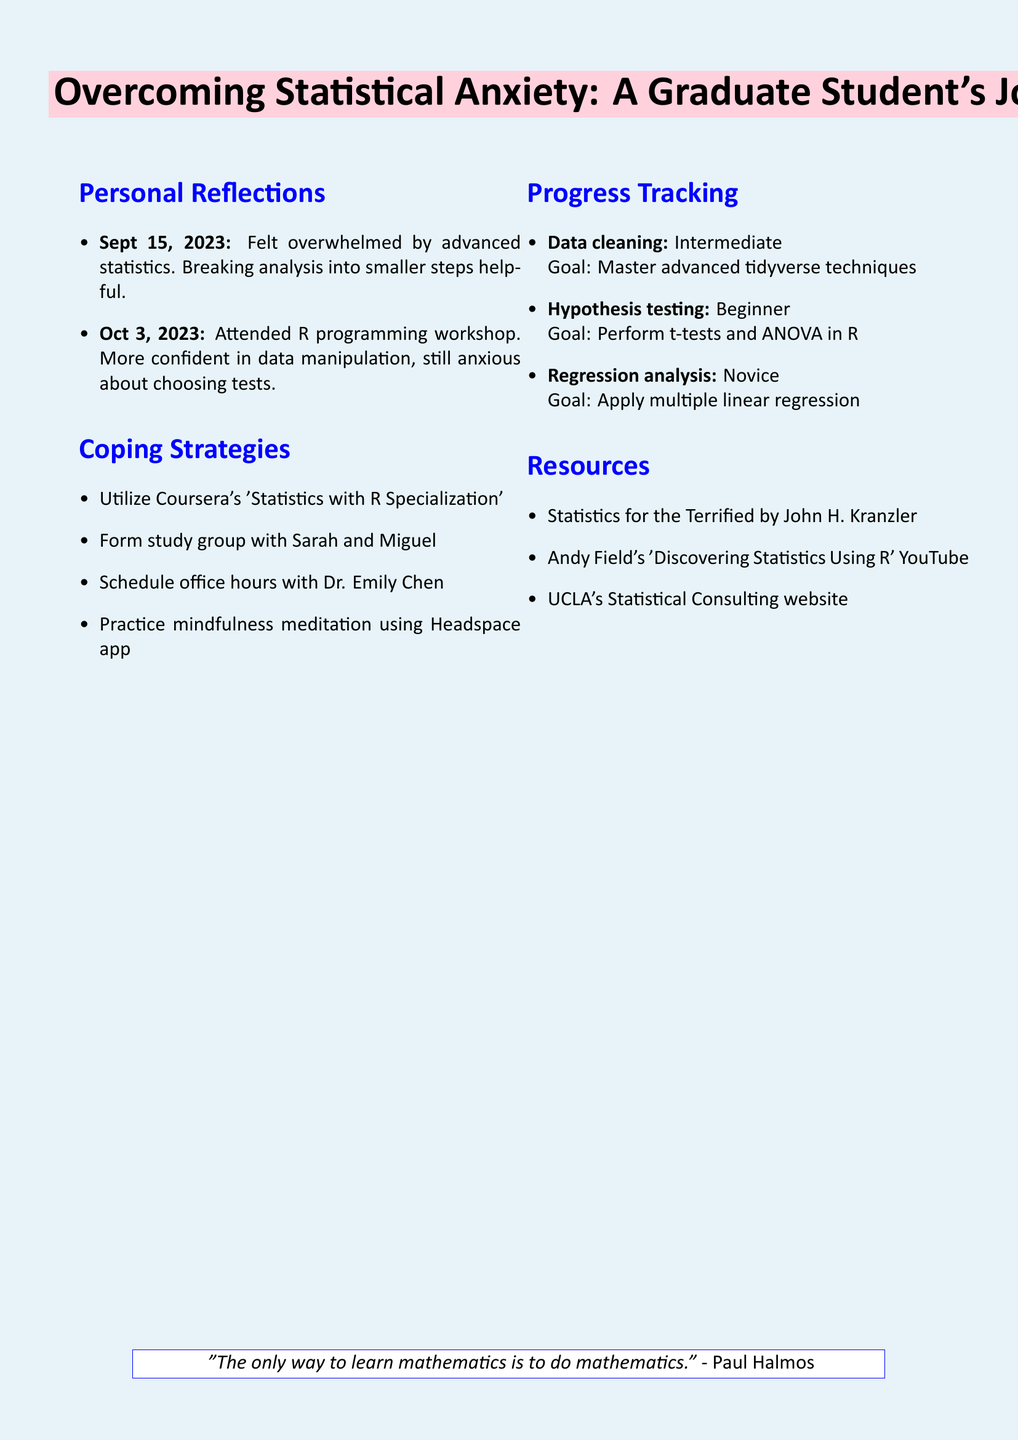What is the title of the document? The title is indicated at the start of the notes, summarizing the content and journey of the graduate student.
Answer: Overcoming Statistical Anxiety: A Graduate Student's Journey On what date did the student feel overwhelmed by advanced statistics? The reflection dates are provided, which directly correspond to moments of anxiety in the student's journey.
Answer: September 15, 2023 Who suggested breaking down the analysis into smaller steps? The notes specify that this suggestion came from a specific individual in the context of coping with anxiety.
Answer: Dr. Johnson What is the proficiency level in hypothesis testing? There is a clear categorization of skill proficiency levels offered in the progress tracking section of the document.
Answer: Beginner What mindfulness app is mentioned for managing anxiety? The document provides resources and methods for coping, including specific applications that can help.
Answer: Headspace What is the next goal for regression analysis proficiency? The progress tracking section outlines the next steps for each skill area as goals to achieve.
Answer: Understand and apply multiple linear regression Name one resource listed for learning statistics. Resources are provided to help supplement the student's learning and assist in overcoming anxiety.
Answer: Statistics for the Terrified by John H. Kranzler Who are the student’s classmates mentioned for the study group? The coping strategies section lists individuals who are part of the student's support system.
Answer: Sarah and Miguel What quote is included at the end of the document? The document concludes with an inspirational quote, which can provide motivation and context.
Answer: The only way to learn mathematics is to do mathematics. - Paul Halmos 